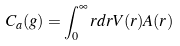<formula> <loc_0><loc_0><loc_500><loc_500>C _ { a } ( g ) = \int _ { 0 } ^ { \infty } r d r V ( r ) A ( r )</formula> 